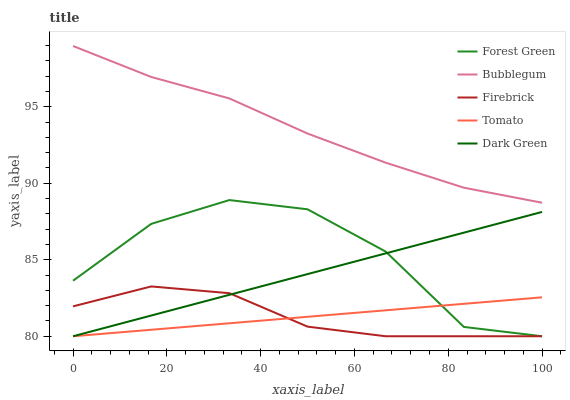Does Tomato have the minimum area under the curve?
Answer yes or no. Yes. Does Bubblegum have the maximum area under the curve?
Answer yes or no. Yes. Does Forest Green have the minimum area under the curve?
Answer yes or no. No. Does Forest Green have the maximum area under the curve?
Answer yes or no. No. Is Dark Green the smoothest?
Answer yes or no. Yes. Is Forest Green the roughest?
Answer yes or no. Yes. Is Firebrick the smoothest?
Answer yes or no. No. Is Firebrick the roughest?
Answer yes or no. No. Does Tomato have the lowest value?
Answer yes or no. Yes. Does Bubblegum have the lowest value?
Answer yes or no. No. Does Bubblegum have the highest value?
Answer yes or no. Yes. Does Forest Green have the highest value?
Answer yes or no. No. Is Dark Green less than Bubblegum?
Answer yes or no. Yes. Is Bubblegum greater than Forest Green?
Answer yes or no. Yes. Does Dark Green intersect Forest Green?
Answer yes or no. Yes. Is Dark Green less than Forest Green?
Answer yes or no. No. Is Dark Green greater than Forest Green?
Answer yes or no. No. Does Dark Green intersect Bubblegum?
Answer yes or no. No. 